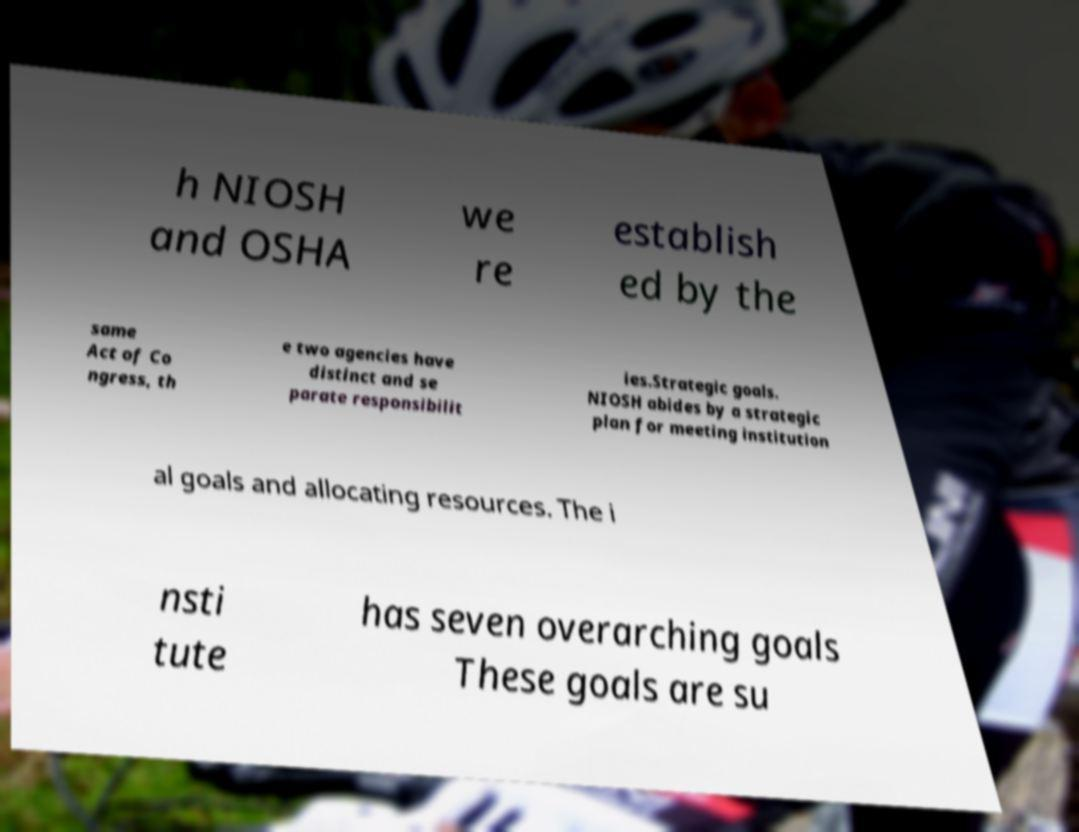Can you accurately transcribe the text from the provided image for me? h NIOSH and OSHA we re establish ed by the same Act of Co ngress, th e two agencies have distinct and se parate responsibilit ies.Strategic goals. NIOSH abides by a strategic plan for meeting institution al goals and allocating resources. The i nsti tute has seven overarching goals These goals are su 